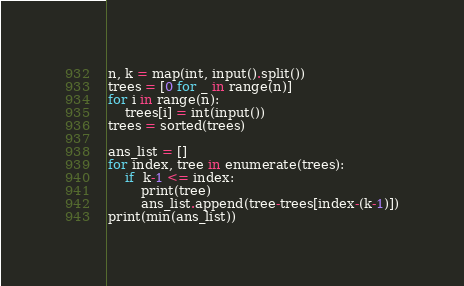<code> <loc_0><loc_0><loc_500><loc_500><_Python_>n, k = map(int, input().split())
trees = [0 for _ in range(n)]
for i in range(n):
    trees[i] = int(input())
trees = sorted(trees)

ans_list = []
for index, tree in enumerate(trees):
    if  k-1 <= index:
        print(tree)
        ans_list.append(tree-trees[index-(k-1)])
print(min(ans_list))
</code> 